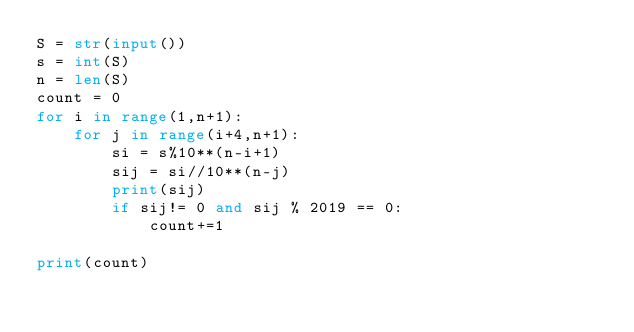<code> <loc_0><loc_0><loc_500><loc_500><_Python_>S = str(input())
s = int(S)
n = len(S)
count = 0
for i in range(1,n+1):
    for j in range(i+4,n+1):
        si = s%10**(n-i+1)
        sij = si//10**(n-j)
        print(sij)
        if sij!= 0 and sij % 2019 == 0:
            count+=1

print(count)</code> 